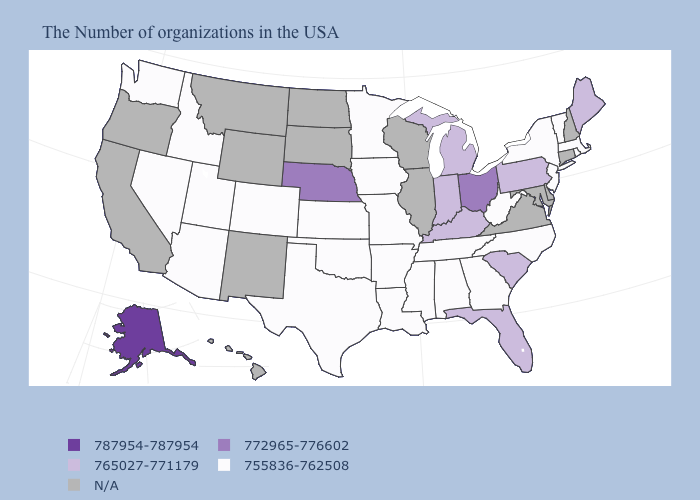Name the states that have a value in the range N/A?
Keep it brief. New Hampshire, Connecticut, Delaware, Maryland, Virginia, Wisconsin, Illinois, South Dakota, North Dakota, Wyoming, New Mexico, Montana, California, Oregon, Hawaii. What is the value of Arkansas?
Concise answer only. 755836-762508. Which states have the lowest value in the MidWest?
Keep it brief. Missouri, Minnesota, Iowa, Kansas. Which states hav the highest value in the West?
Be succinct. Alaska. What is the lowest value in states that border Florida?
Answer briefly. 755836-762508. Does Indiana have the lowest value in the USA?
Quick response, please. No. Does Michigan have the lowest value in the USA?
Be succinct. No. Among the states that border Rhode Island , which have the highest value?
Short answer required. Massachusetts. Does the first symbol in the legend represent the smallest category?
Keep it brief. No. What is the lowest value in the USA?
Short answer required. 755836-762508. 